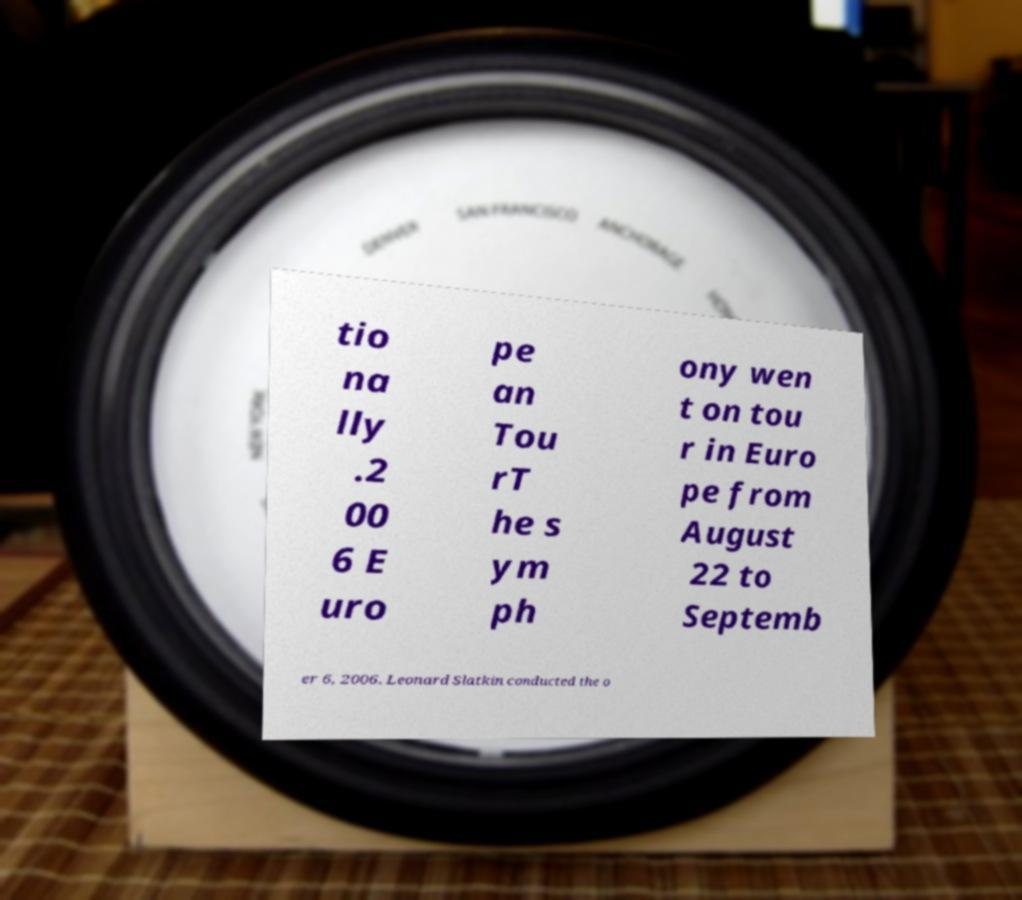There's text embedded in this image that I need extracted. Can you transcribe it verbatim? tio na lly .2 00 6 E uro pe an Tou rT he s ym ph ony wen t on tou r in Euro pe from August 22 to Septemb er 6, 2006. Leonard Slatkin conducted the o 